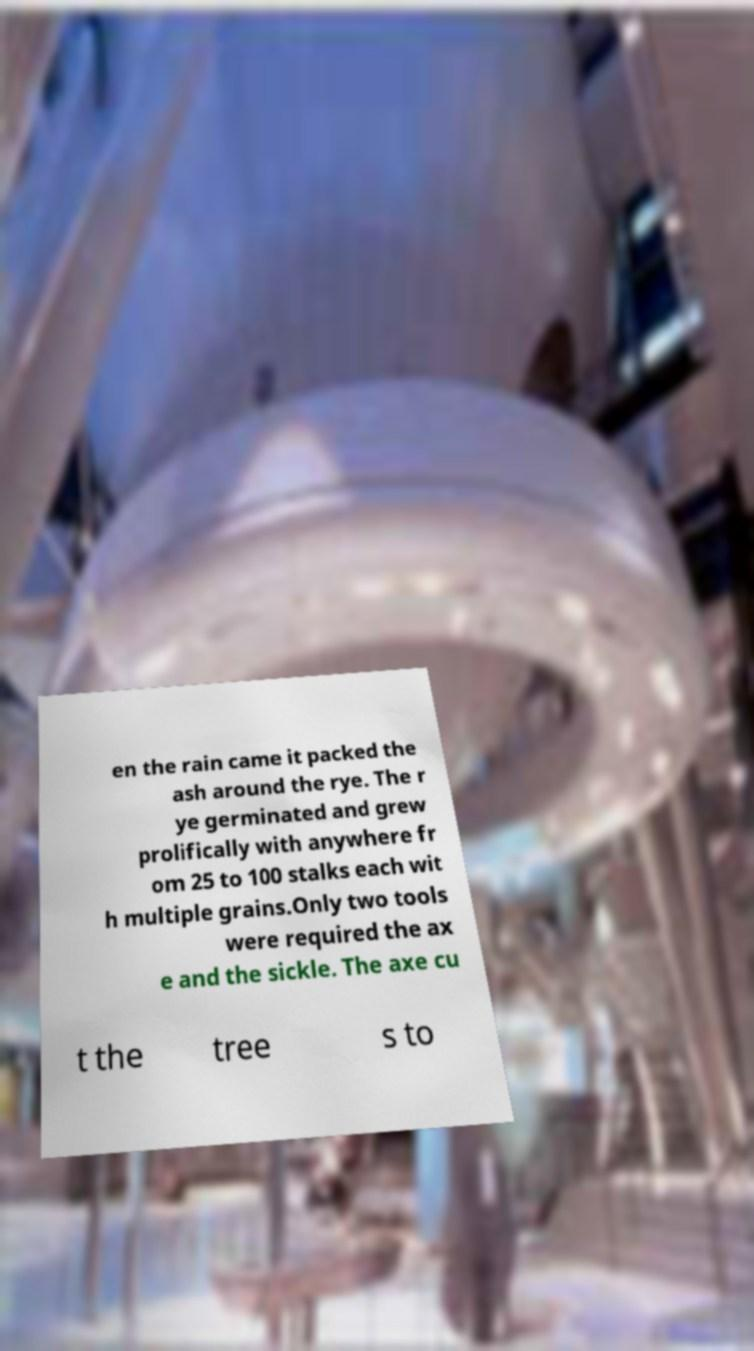For documentation purposes, I need the text within this image transcribed. Could you provide that? en the rain came it packed the ash around the rye. The r ye germinated and grew prolifically with anywhere fr om 25 to 100 stalks each wit h multiple grains.Only two tools were required the ax e and the sickle. The axe cu t the tree s to 